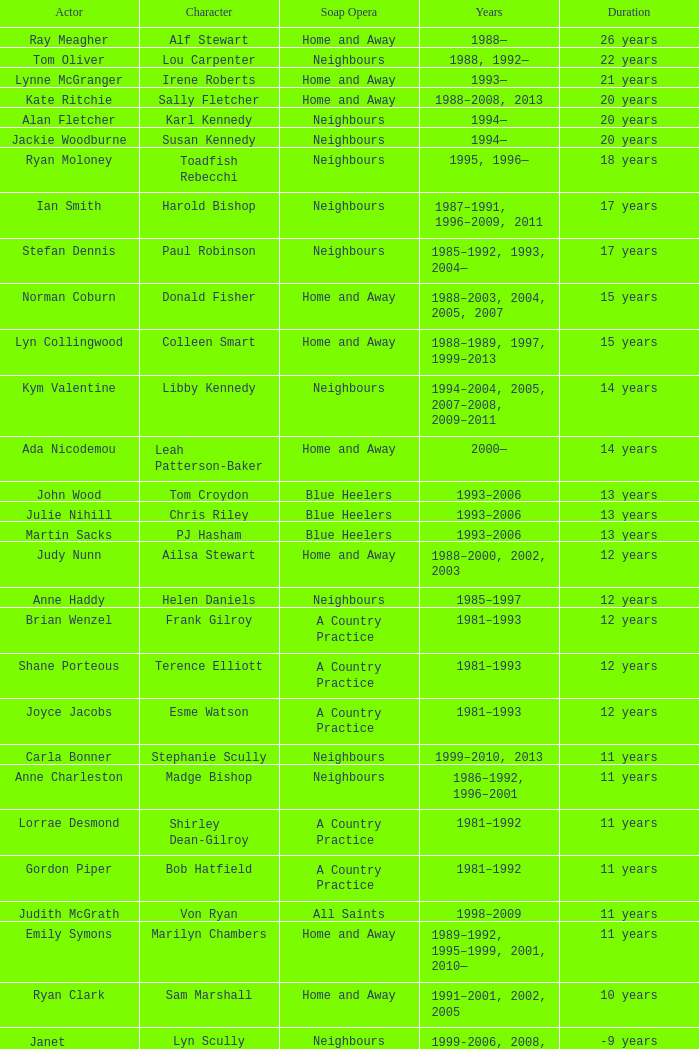Which performer portrayed harold bishop for 17 years? Ian Smith. 